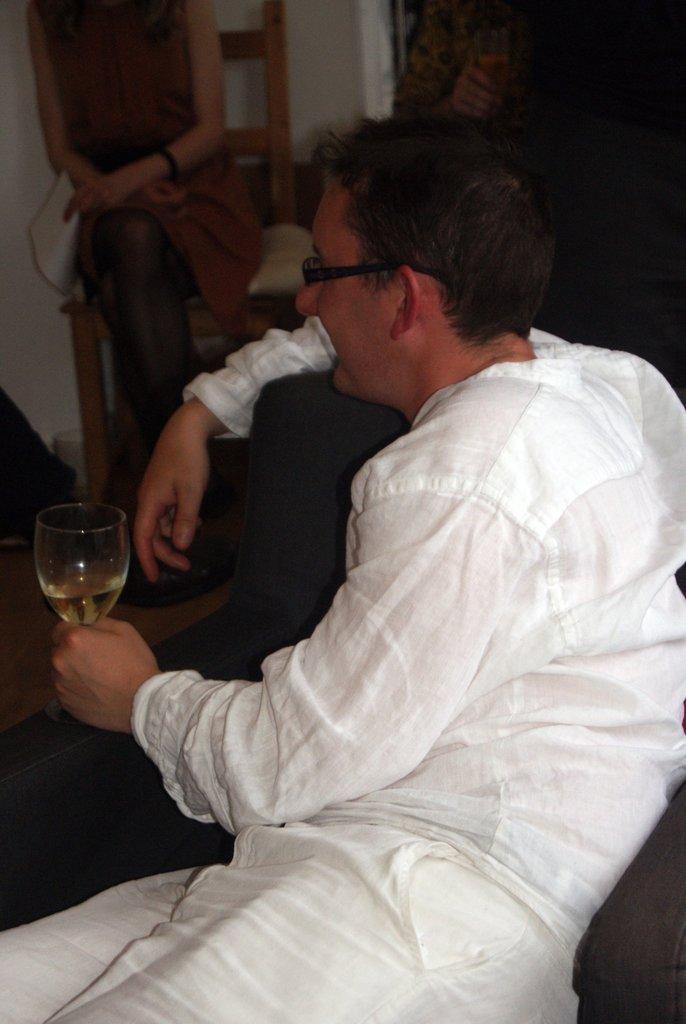In one or two sentences, can you explain what this image depicts? In this image the man is wearing white dress and holding a wine glass in his left hand. In the background of the image we can see a woman sitting on the chair and holding few papers. 